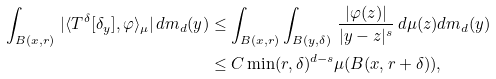Convert formula to latex. <formula><loc_0><loc_0><loc_500><loc_500>\int _ { B ( x , r ) } \, | \langle T ^ { \delta } [ \delta _ { y } ] , \varphi \rangle _ { \mu } | \, d m _ { d } ( y ) & \leq \int _ { B ( x , r ) } \int _ { B ( y , \delta ) } \, \frac { | \varphi ( z ) | } { | y - z | ^ { s } } \, d \mu ( z ) d m _ { d } ( y ) \\ & \leq C \min ( r , \delta ) ^ { d - s } \mu ( B ( x , r + \delta ) ) ,</formula> 